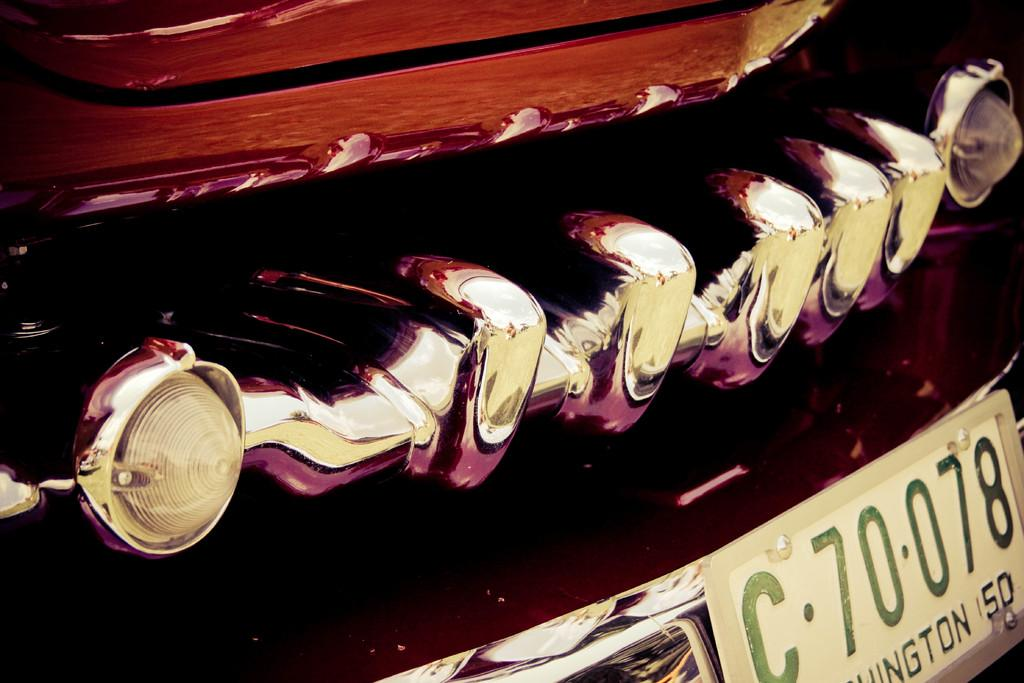What is the main subject of the image? The main subject of the image is a vehicle bumper. Is there any additional information visible on the bumper? Yes, there is a number plate in the bottom right corner of the image. Where is the mountain located in the image? There is no mountain present in the image; it only features a vehicle bumper and a number plate. 